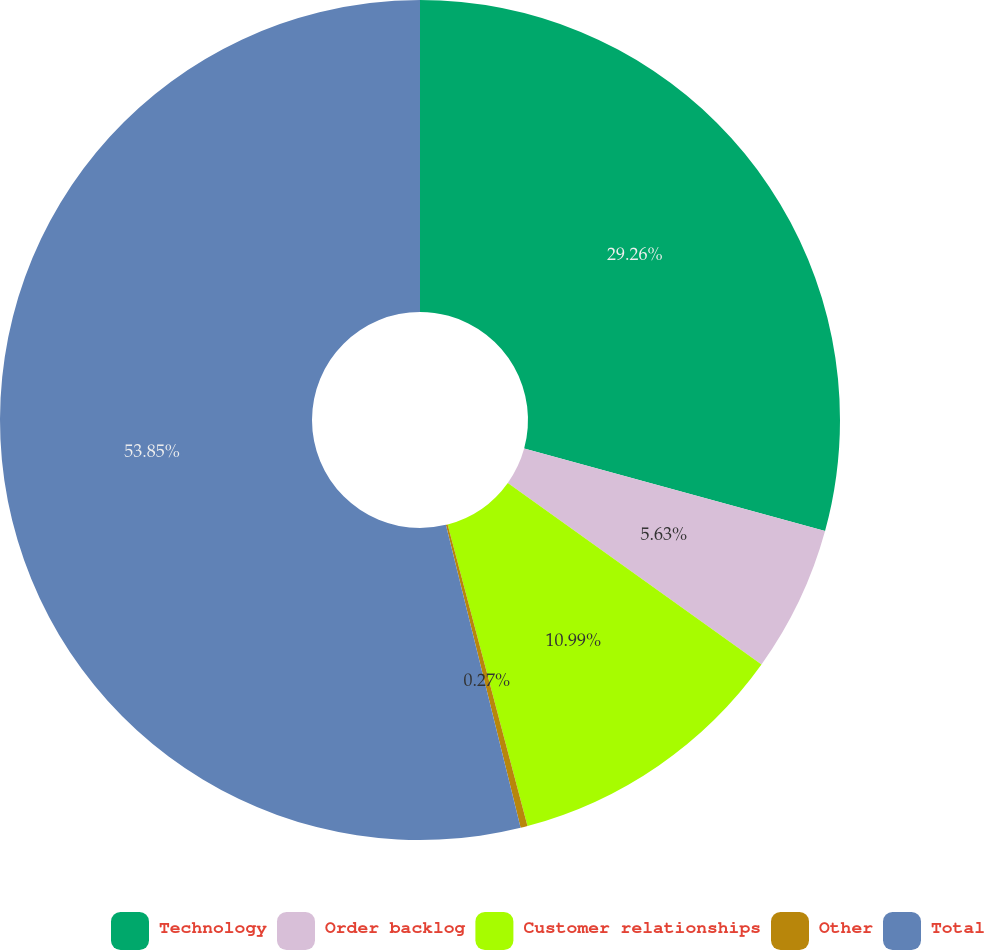Convert chart. <chart><loc_0><loc_0><loc_500><loc_500><pie_chart><fcel>Technology<fcel>Order backlog<fcel>Customer relationships<fcel>Other<fcel>Total<nl><fcel>29.26%<fcel>5.63%<fcel>10.99%<fcel>0.27%<fcel>53.85%<nl></chart> 